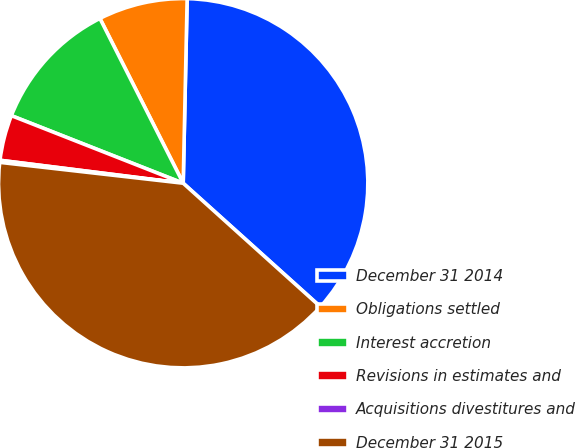Convert chart to OTSL. <chart><loc_0><loc_0><loc_500><loc_500><pie_chart><fcel>December 31 2014<fcel>Obligations settled<fcel>Interest accretion<fcel>Revisions in estimates and<fcel>Acquisitions divestitures and<fcel>December 31 2015<nl><fcel>36.33%<fcel>7.79%<fcel>11.59%<fcel>3.98%<fcel>0.18%<fcel>40.14%<nl></chart> 